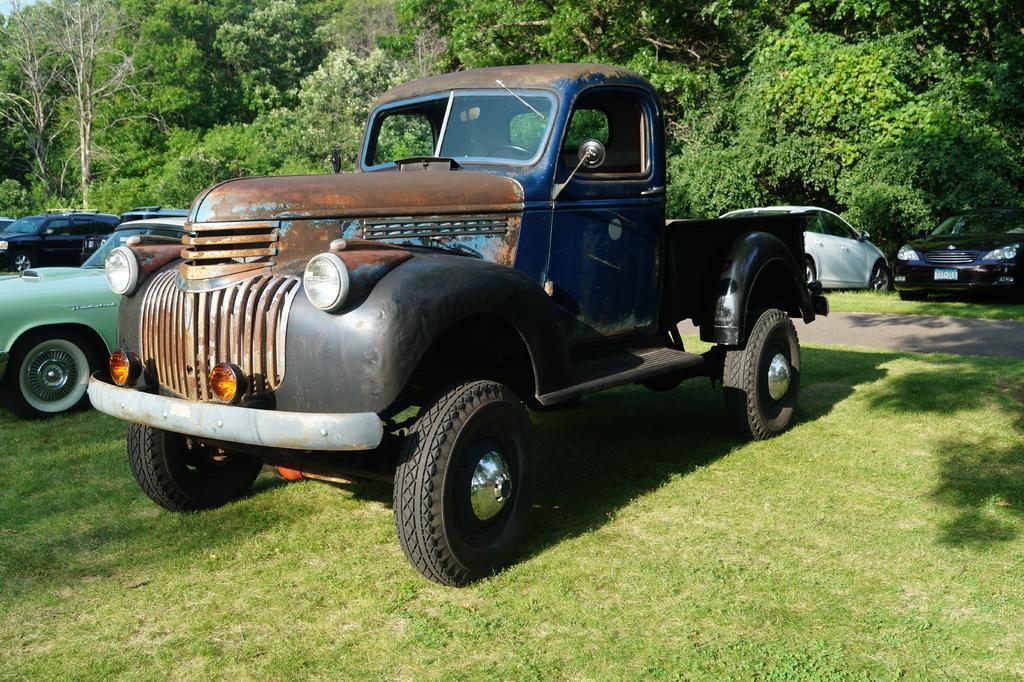Describe this image in one or two sentences. In this image there are vehicle on a grassland, in the background there is a road and trees. 